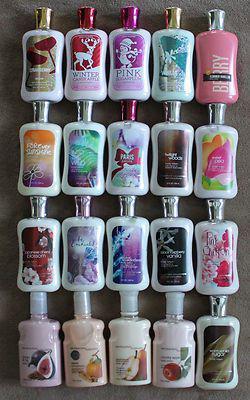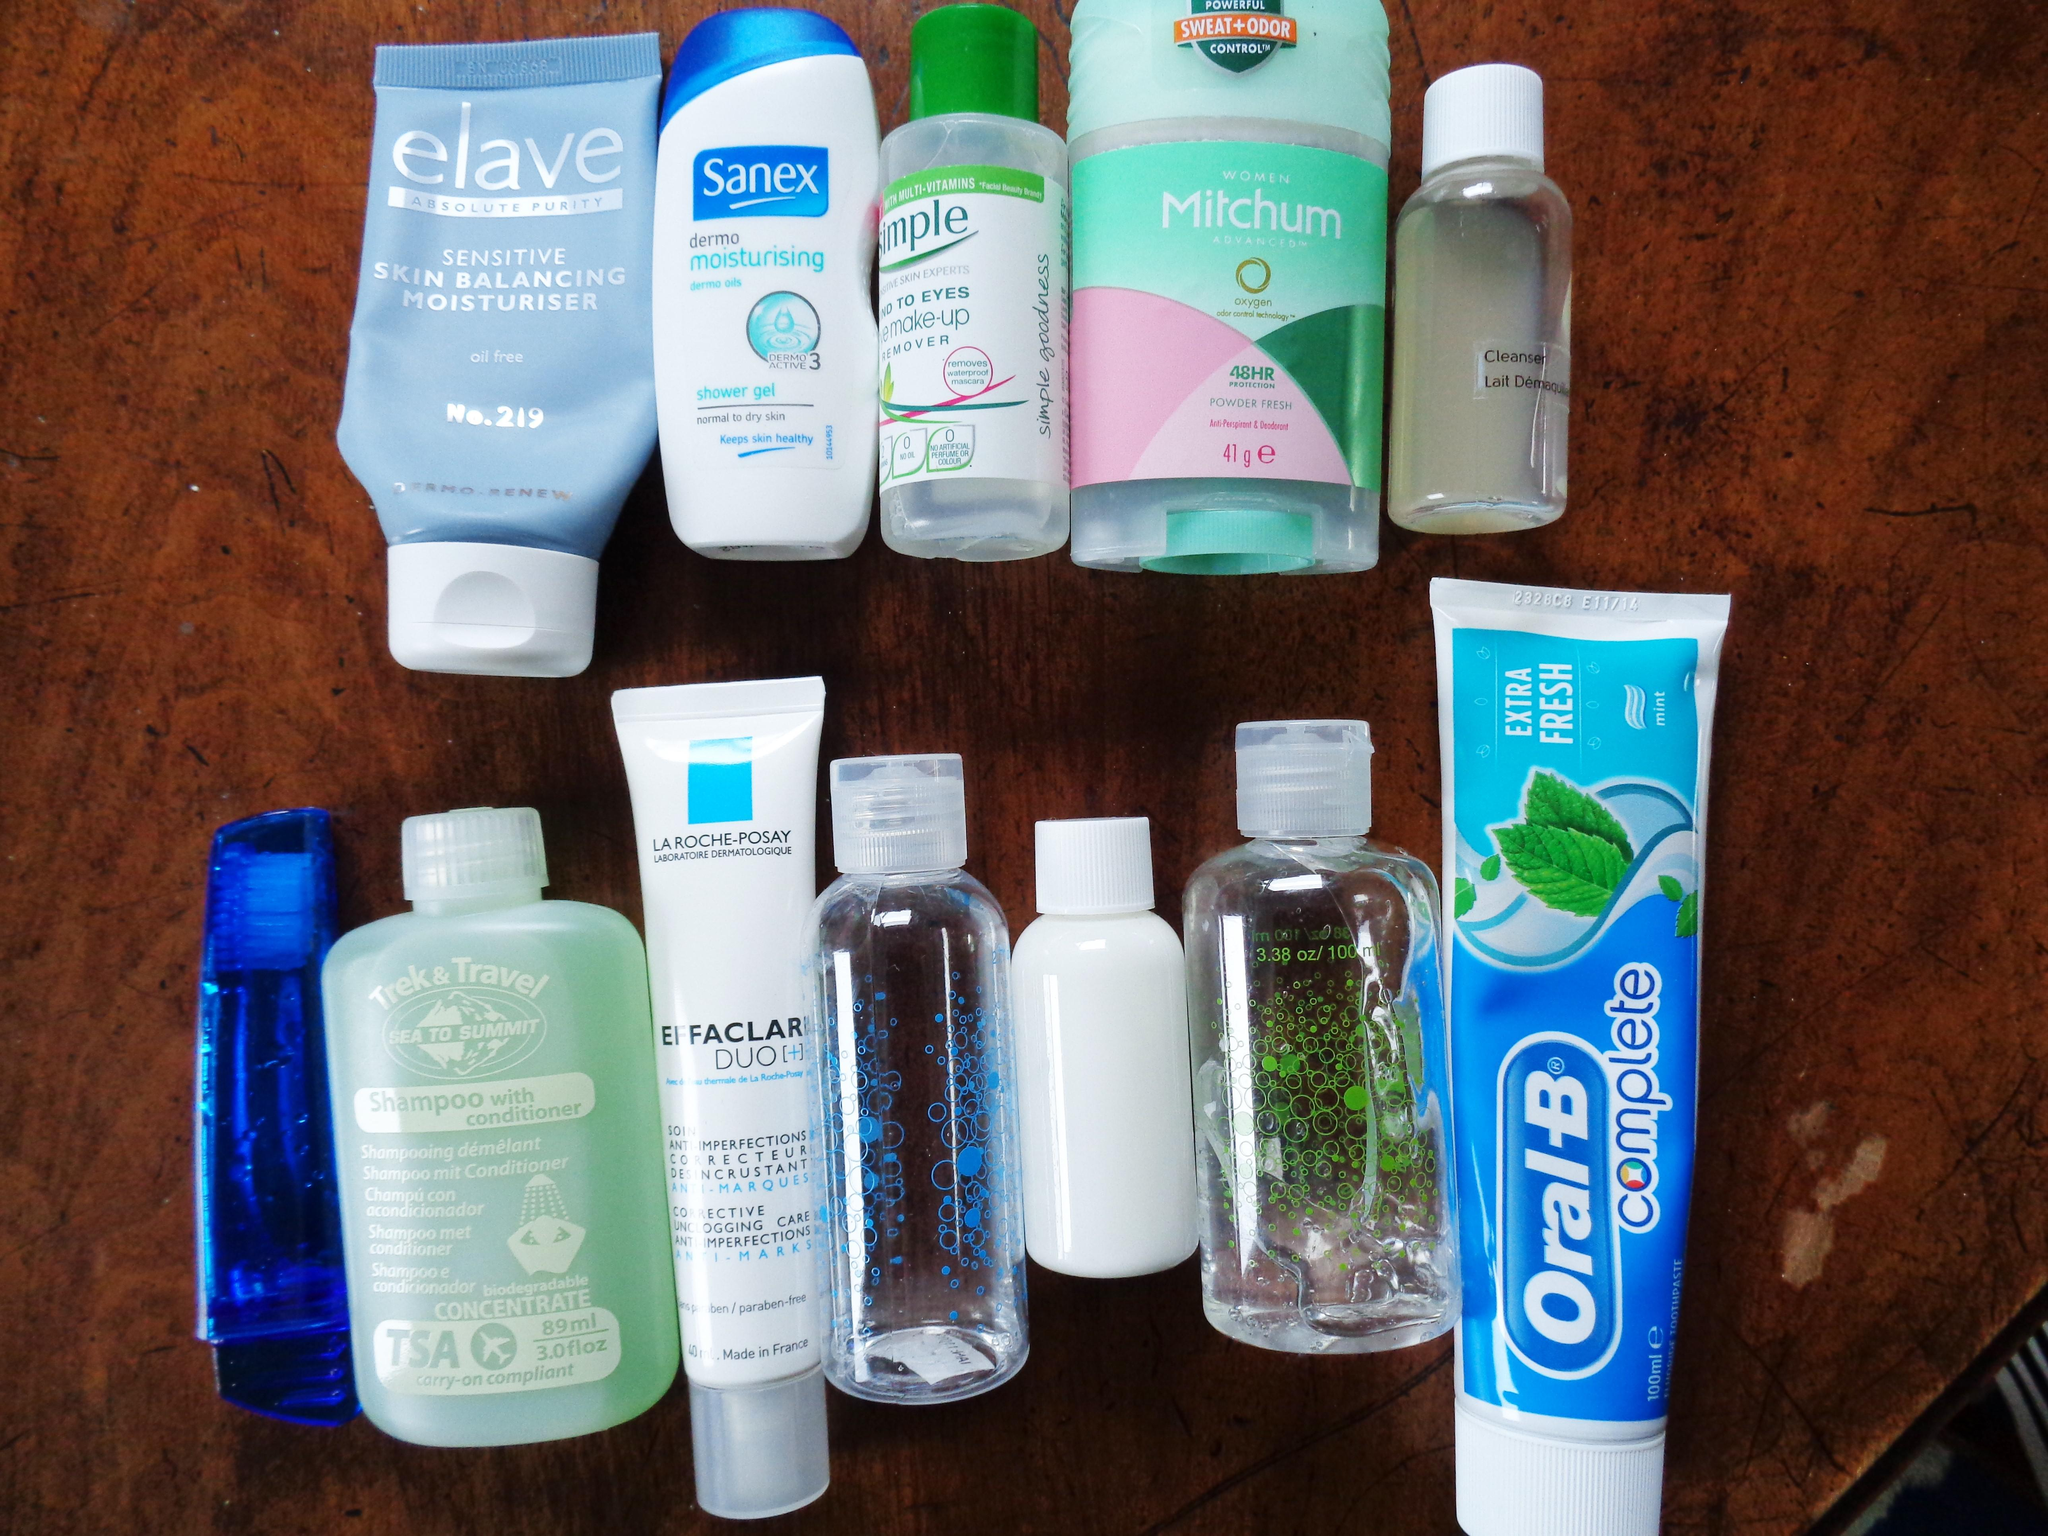The first image is the image on the left, the second image is the image on the right. Analyze the images presented: Is the assertion "At least one image has exactly three containers." valid? Answer yes or no. No. The first image is the image on the left, the second image is the image on the right. Evaluate the accuracy of this statement regarding the images: "There are many bathroom items, and not just makeup and lotion.". Is it true? Answer yes or no. Yes. 